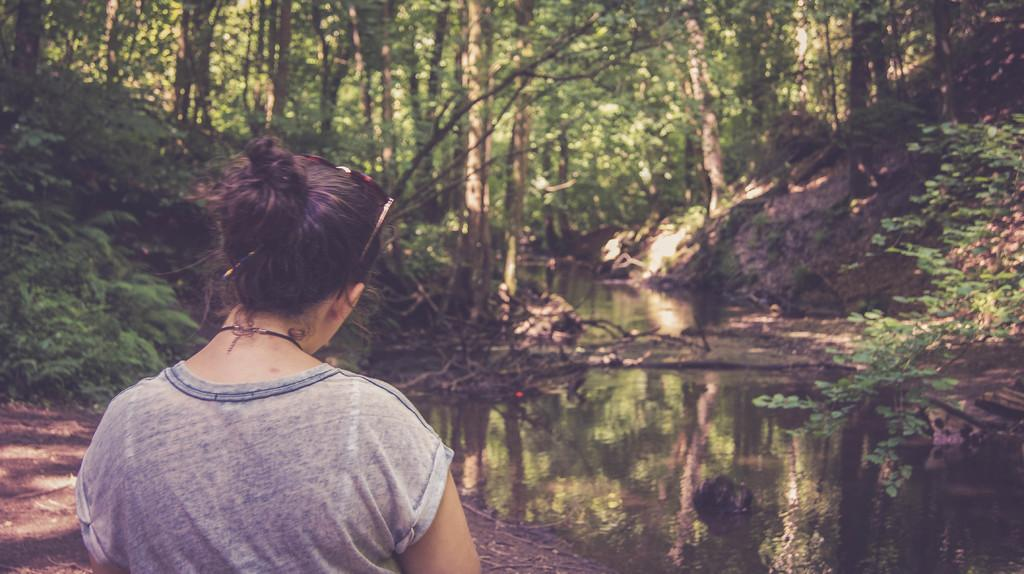Who is the main subject on the left side of the image? There is a lady on the left side of the image. What is present at the bottom side of the image? There is water at the bottom side of the image. What can be seen in the background of the image? There are trees in the background area of the image. What type of meal is being prepared by the lady in the image? There is no indication in the image that the lady is preparing a meal, so it cannot be determined from the picture. 